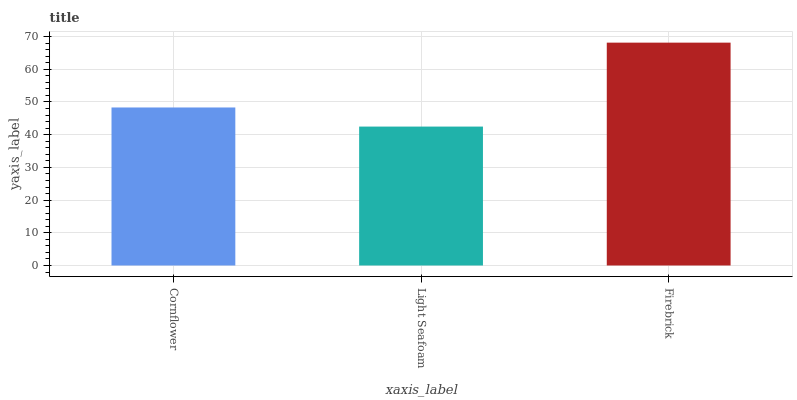Is Light Seafoam the minimum?
Answer yes or no. Yes. Is Firebrick the maximum?
Answer yes or no. Yes. Is Firebrick the minimum?
Answer yes or no. No. Is Light Seafoam the maximum?
Answer yes or no. No. Is Firebrick greater than Light Seafoam?
Answer yes or no. Yes. Is Light Seafoam less than Firebrick?
Answer yes or no. Yes. Is Light Seafoam greater than Firebrick?
Answer yes or no. No. Is Firebrick less than Light Seafoam?
Answer yes or no. No. Is Cornflower the high median?
Answer yes or no. Yes. Is Cornflower the low median?
Answer yes or no. Yes. Is Firebrick the high median?
Answer yes or no. No. Is Light Seafoam the low median?
Answer yes or no. No. 